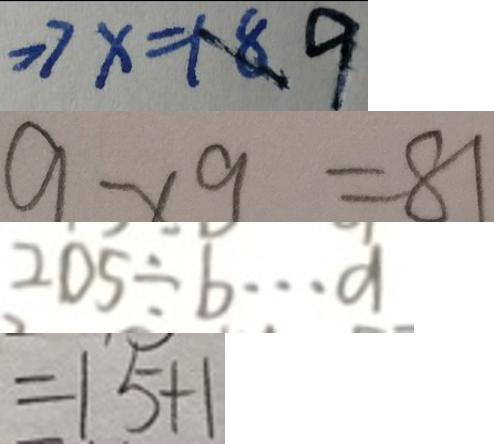Convert formula to latex. <formula><loc_0><loc_0><loc_500><loc_500>> 7 x = 1 8 9 
 9 \times 9 = 8 1 
 2 0 5 \div b \cdots a 
 = 1 5 + 1</formula> 